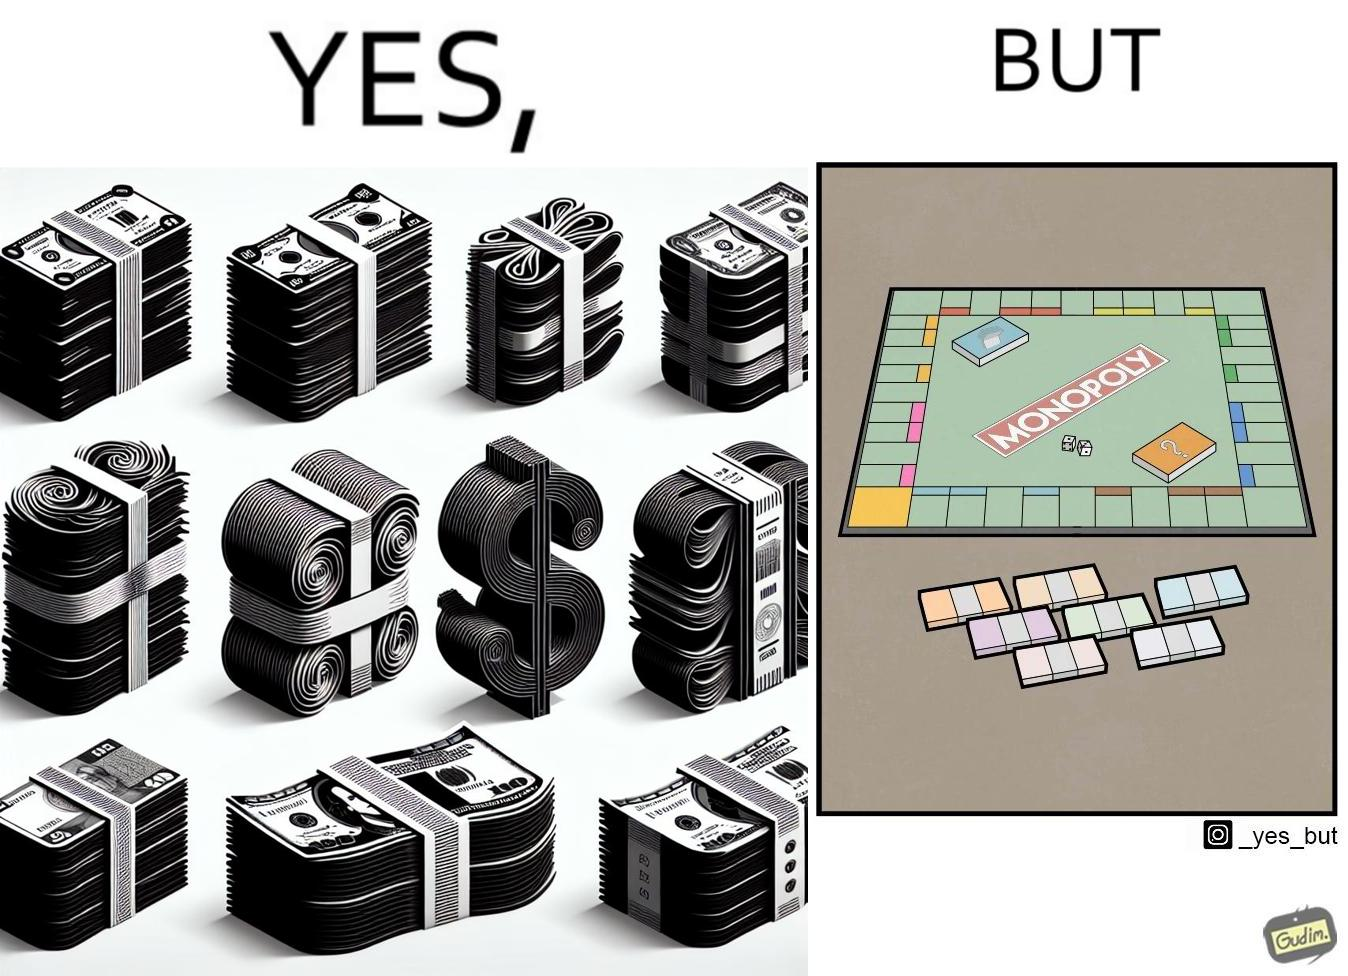Describe what you see in the left and right parts of this image. In the left part of the image: many different color currency notes' bundles In the right part of the image: a board of game monopoly with many different color currency notes' bundles 